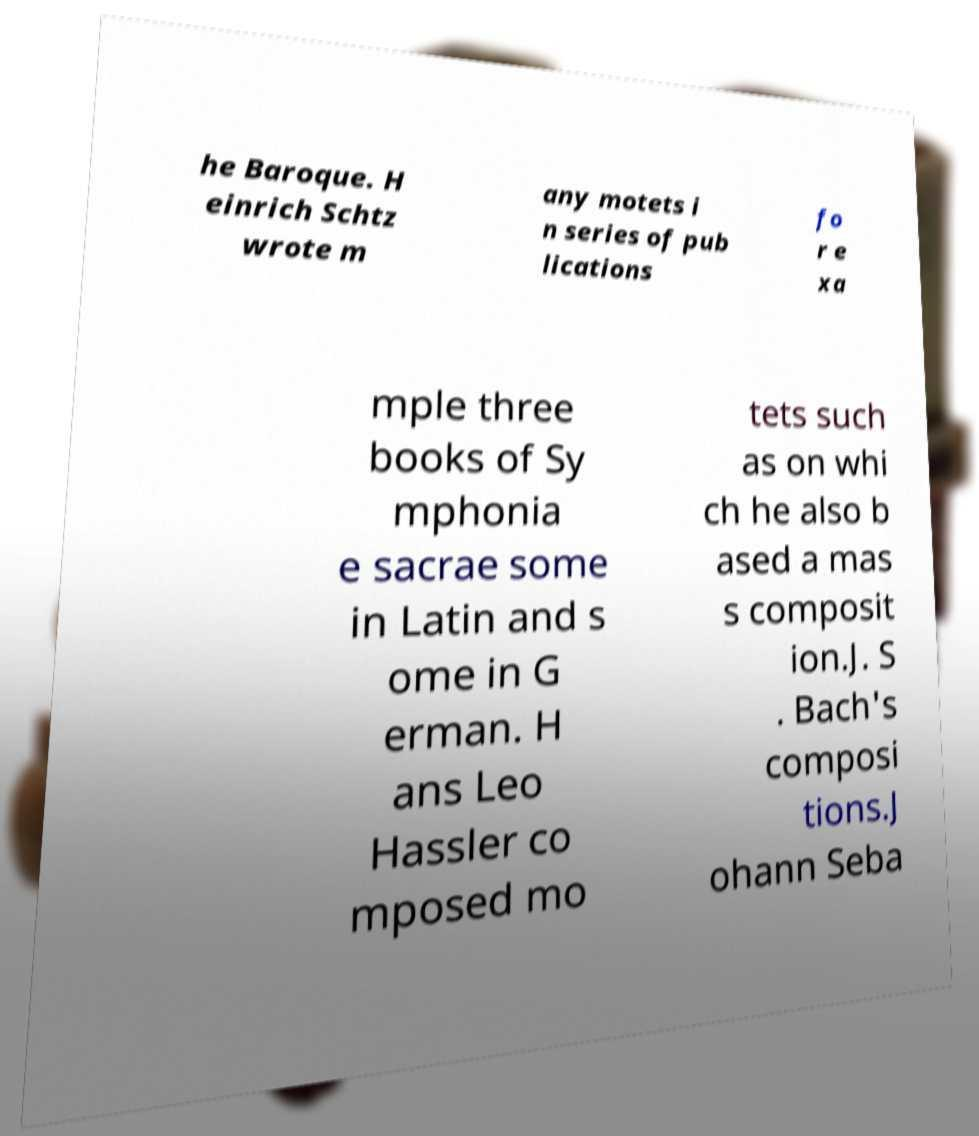Please read and relay the text visible in this image. What does it say? he Baroque. H einrich Schtz wrote m any motets i n series of pub lications fo r e xa mple three books of Sy mphonia e sacrae some in Latin and s ome in G erman. H ans Leo Hassler co mposed mo tets such as on whi ch he also b ased a mas s composit ion.J. S . Bach's composi tions.J ohann Seba 